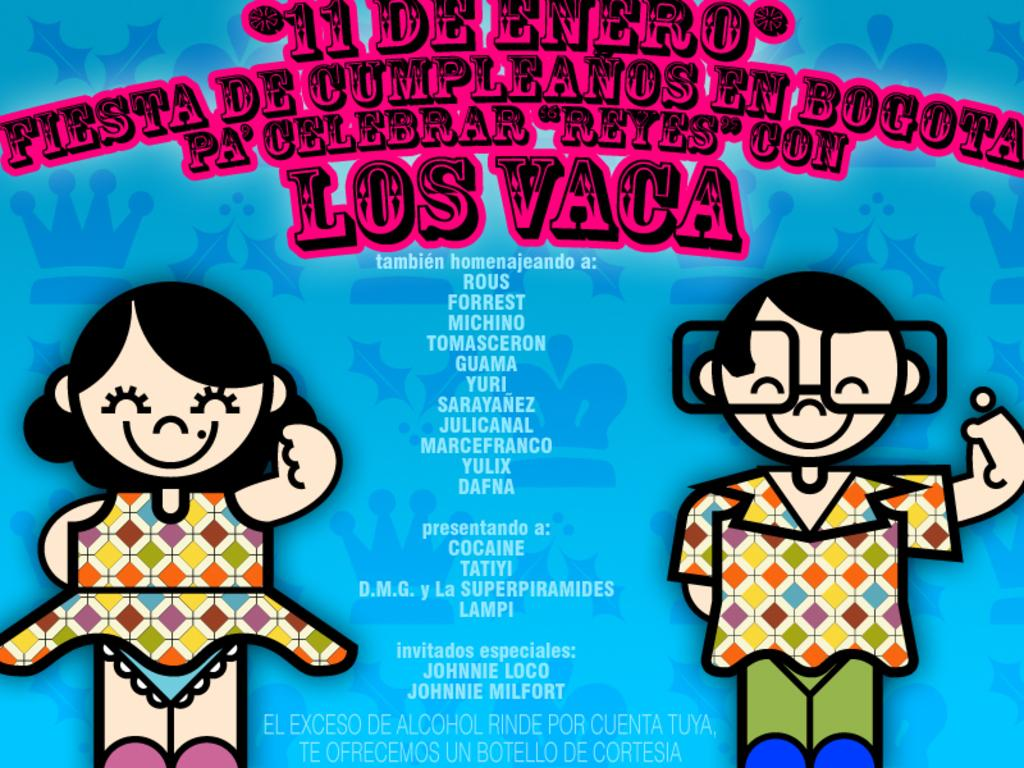What is featured in the picture? There is a poster in the picture. What can be found on the poster? The poster contains text and cartoon images. What type of coat is the porter wearing in the image? There is no porter or coat present in the image; it only features a poster with text and cartoon images. 